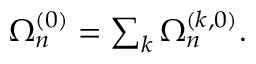<formula> <loc_0><loc_0><loc_500><loc_500>\begin{array} { r } { \Omega _ { n } ^ { ( 0 ) } = \sum _ { k } \Omega _ { n } ^ { ( k , 0 ) } . } \end{array}</formula> 